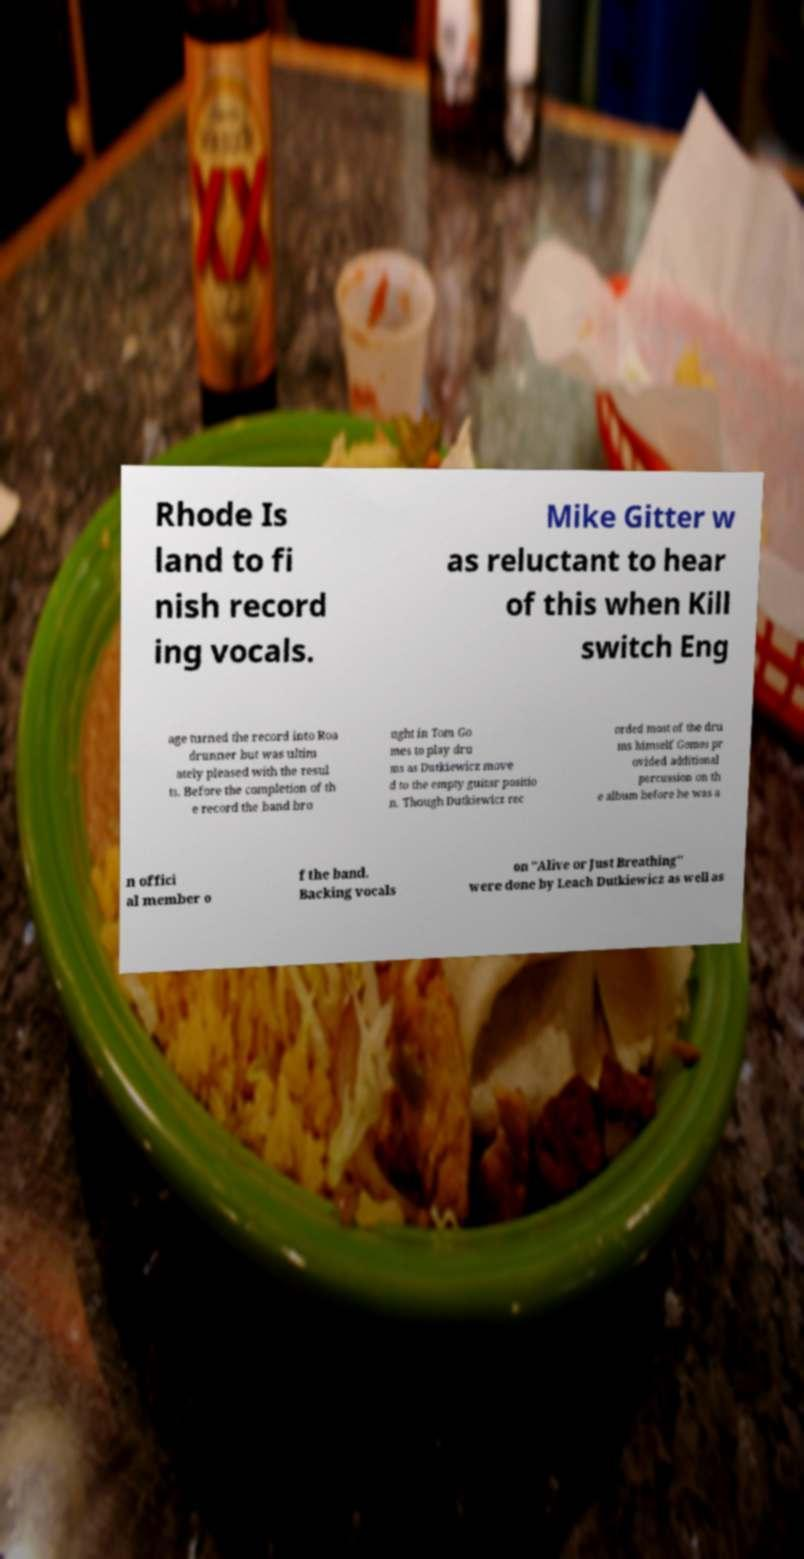I need the written content from this picture converted into text. Can you do that? Rhode Is land to fi nish record ing vocals. Mike Gitter w as reluctant to hear of this when Kill switch Eng age turned the record into Roa drunner but was ultim ately pleased with the resul ts. Before the completion of th e record the band bro ught in Tom Go mes to play dru ms as Dutkiewicz move d to the empty guitar positio n. Though Dutkiewicz rec orded most of the dru ms himself Gomes pr ovided additional percussion on th e album before he was a n offici al member o f the band. Backing vocals on "Alive or Just Breathing" were done by Leach Dutkiewicz as well as 